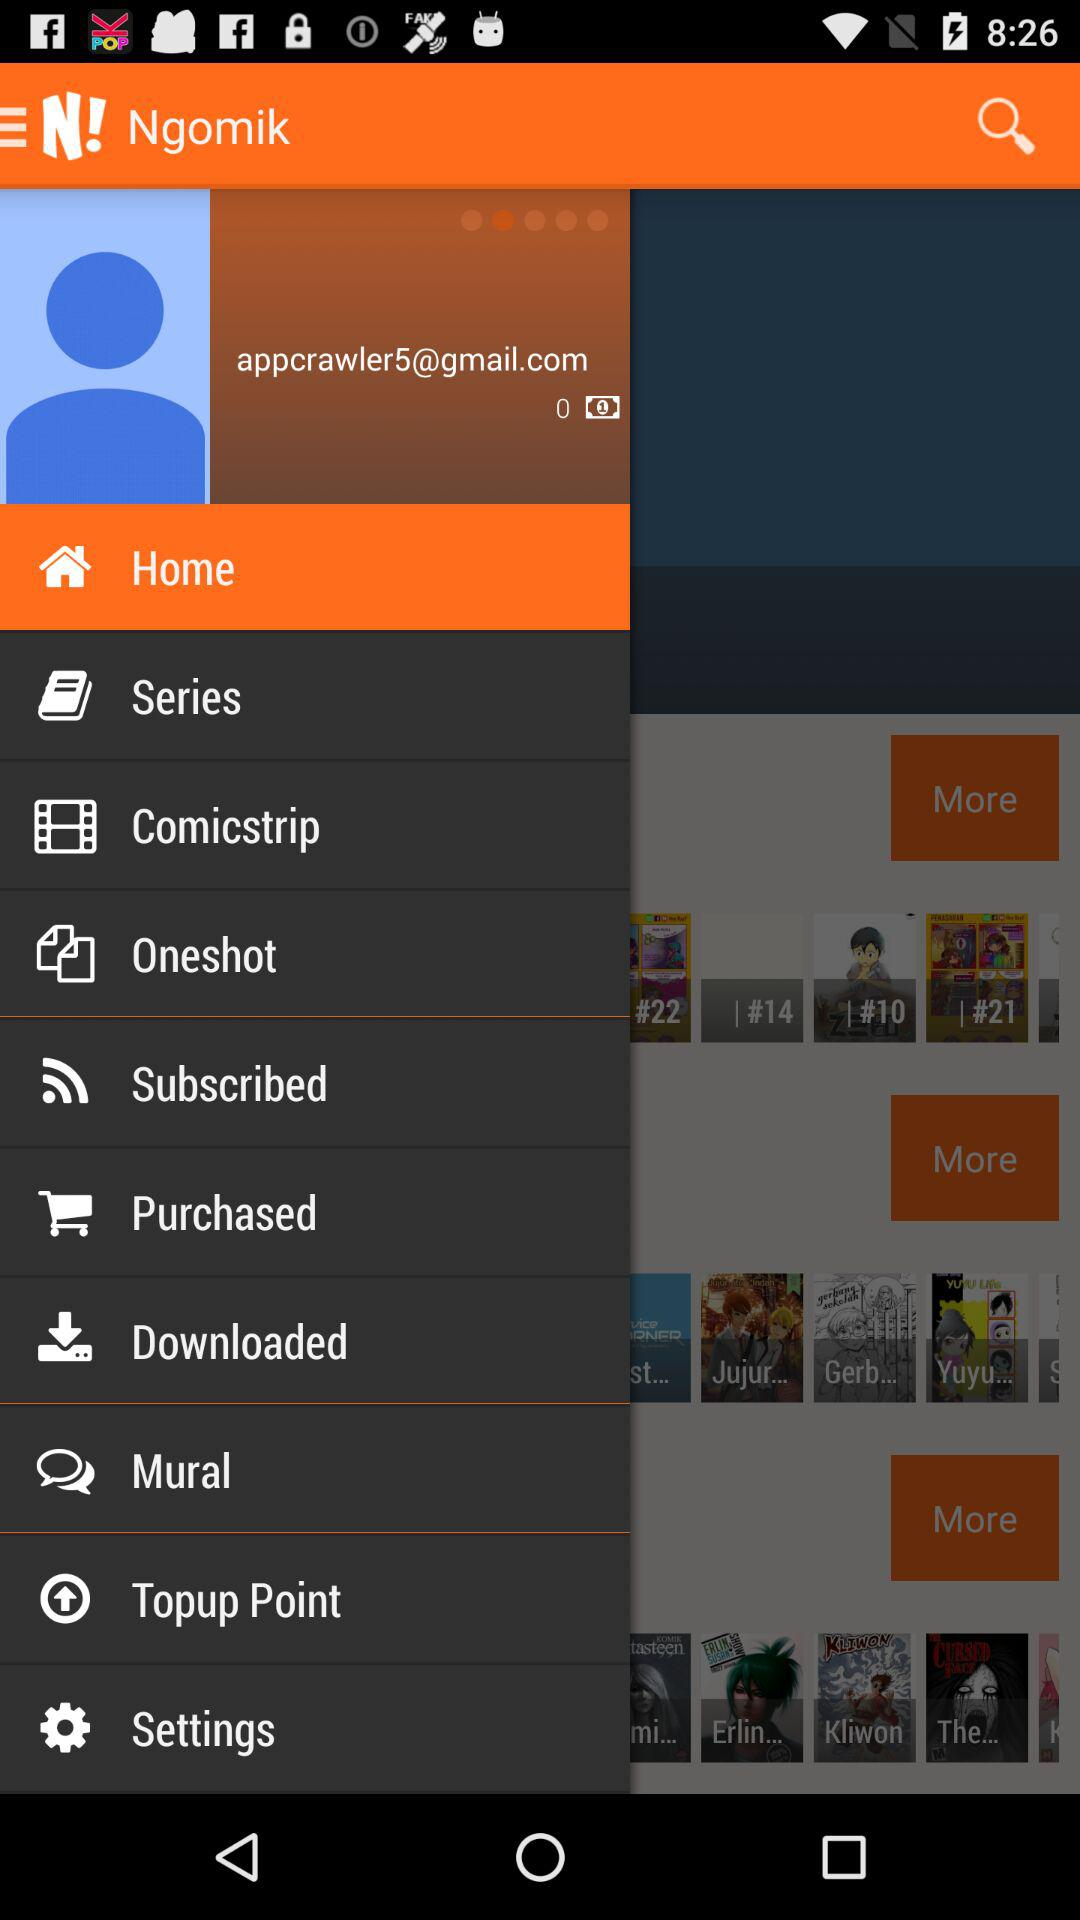What is the email ID of the user? The email ID of the user is appcrawler5@gmail.com. 